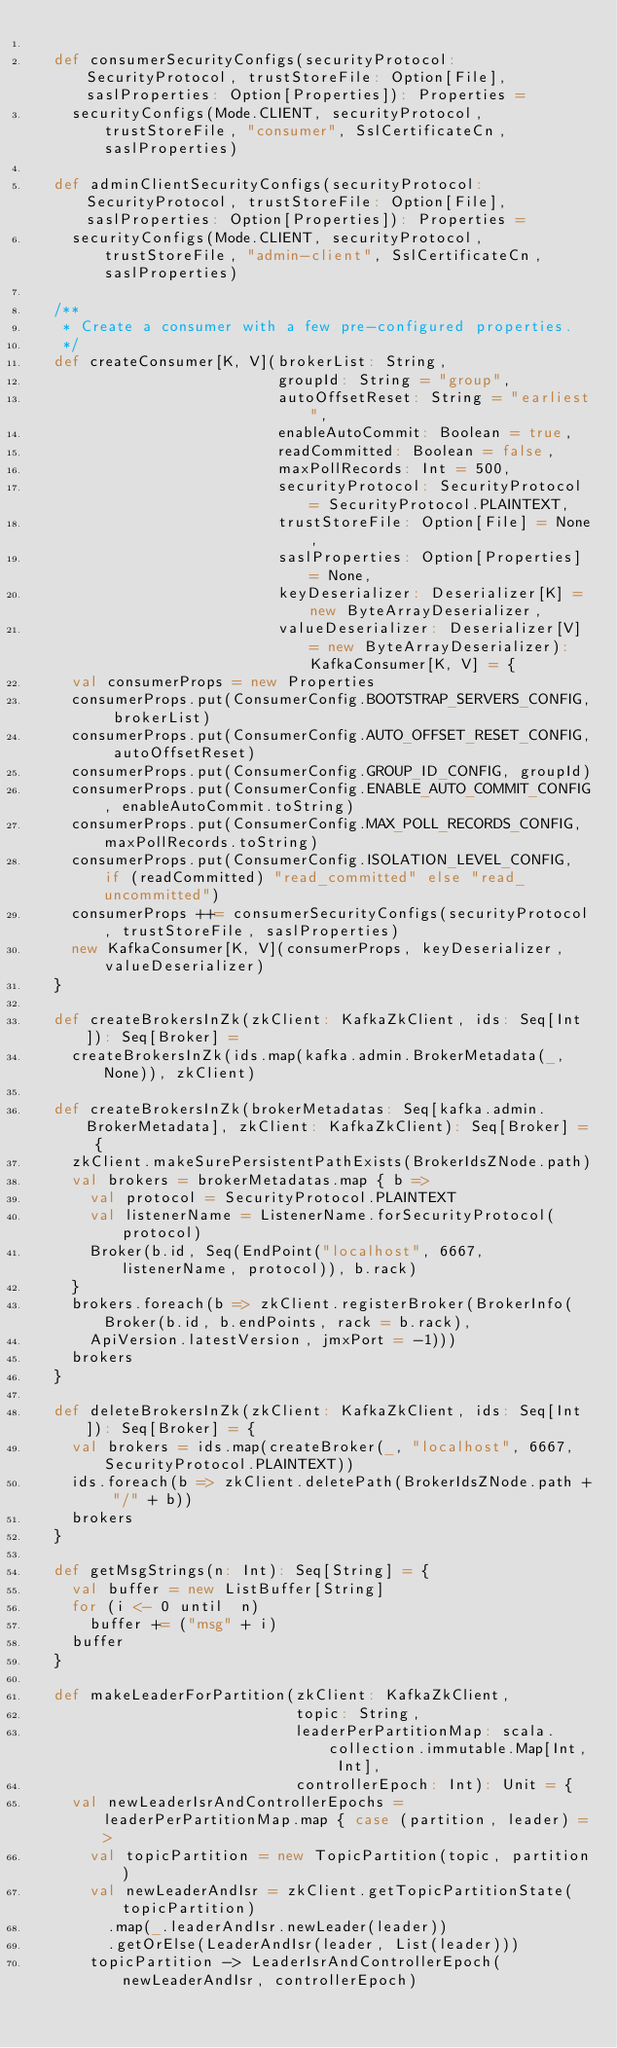<code> <loc_0><loc_0><loc_500><loc_500><_Scala_>
  def consumerSecurityConfigs(securityProtocol: SecurityProtocol, trustStoreFile: Option[File], saslProperties: Option[Properties]): Properties =
    securityConfigs(Mode.CLIENT, securityProtocol, trustStoreFile, "consumer", SslCertificateCn, saslProperties)

  def adminClientSecurityConfigs(securityProtocol: SecurityProtocol, trustStoreFile: Option[File], saslProperties: Option[Properties]): Properties =
    securityConfigs(Mode.CLIENT, securityProtocol, trustStoreFile, "admin-client", SslCertificateCn, saslProperties)

  /**
   * Create a consumer with a few pre-configured properties.
   */
  def createConsumer[K, V](brokerList: String,
                           groupId: String = "group",
                           autoOffsetReset: String = "earliest",
                           enableAutoCommit: Boolean = true,
                           readCommitted: Boolean = false,
                           maxPollRecords: Int = 500,
                           securityProtocol: SecurityProtocol = SecurityProtocol.PLAINTEXT,
                           trustStoreFile: Option[File] = None,
                           saslProperties: Option[Properties] = None,
                           keyDeserializer: Deserializer[K] = new ByteArrayDeserializer,
                           valueDeserializer: Deserializer[V] = new ByteArrayDeserializer): KafkaConsumer[K, V] = {
    val consumerProps = new Properties
    consumerProps.put(ConsumerConfig.BOOTSTRAP_SERVERS_CONFIG, brokerList)
    consumerProps.put(ConsumerConfig.AUTO_OFFSET_RESET_CONFIG, autoOffsetReset)
    consumerProps.put(ConsumerConfig.GROUP_ID_CONFIG, groupId)
    consumerProps.put(ConsumerConfig.ENABLE_AUTO_COMMIT_CONFIG, enableAutoCommit.toString)
    consumerProps.put(ConsumerConfig.MAX_POLL_RECORDS_CONFIG, maxPollRecords.toString)
    consumerProps.put(ConsumerConfig.ISOLATION_LEVEL_CONFIG, if (readCommitted) "read_committed" else "read_uncommitted")
    consumerProps ++= consumerSecurityConfigs(securityProtocol, trustStoreFile, saslProperties)
    new KafkaConsumer[K, V](consumerProps, keyDeserializer, valueDeserializer)
  }

  def createBrokersInZk(zkClient: KafkaZkClient, ids: Seq[Int]): Seq[Broker] =
    createBrokersInZk(ids.map(kafka.admin.BrokerMetadata(_, None)), zkClient)

  def createBrokersInZk(brokerMetadatas: Seq[kafka.admin.BrokerMetadata], zkClient: KafkaZkClient): Seq[Broker] = {
    zkClient.makeSurePersistentPathExists(BrokerIdsZNode.path)
    val brokers = brokerMetadatas.map { b =>
      val protocol = SecurityProtocol.PLAINTEXT
      val listenerName = ListenerName.forSecurityProtocol(protocol)
      Broker(b.id, Seq(EndPoint("localhost", 6667, listenerName, protocol)), b.rack)
    }
    brokers.foreach(b => zkClient.registerBroker(BrokerInfo(Broker(b.id, b.endPoints, rack = b.rack),
      ApiVersion.latestVersion, jmxPort = -1)))
    brokers
  }

  def deleteBrokersInZk(zkClient: KafkaZkClient, ids: Seq[Int]): Seq[Broker] = {
    val brokers = ids.map(createBroker(_, "localhost", 6667, SecurityProtocol.PLAINTEXT))
    ids.foreach(b => zkClient.deletePath(BrokerIdsZNode.path + "/" + b))
    brokers
  }

  def getMsgStrings(n: Int): Seq[String] = {
    val buffer = new ListBuffer[String]
    for (i <- 0 until  n)
      buffer += ("msg" + i)
    buffer
  }

  def makeLeaderForPartition(zkClient: KafkaZkClient,
                             topic: String,
                             leaderPerPartitionMap: scala.collection.immutable.Map[Int, Int],
                             controllerEpoch: Int): Unit = {
    val newLeaderIsrAndControllerEpochs = leaderPerPartitionMap.map { case (partition, leader) =>
      val topicPartition = new TopicPartition(topic, partition)
      val newLeaderAndIsr = zkClient.getTopicPartitionState(topicPartition)
        .map(_.leaderAndIsr.newLeader(leader))
        .getOrElse(LeaderAndIsr(leader, List(leader)))
      topicPartition -> LeaderIsrAndControllerEpoch(newLeaderAndIsr, controllerEpoch)</code> 